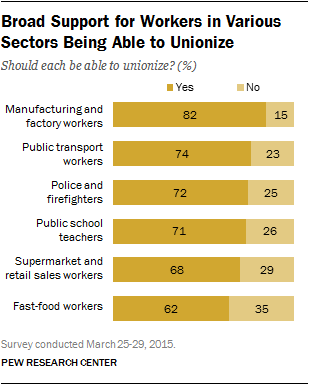Indicate a few pertinent items in this graphic. The category of data is 72 and 25, and it pertains to police and firefighters. In manufacturing and factory work, the ratio of yes to no responses is approximately 82 to 15. 